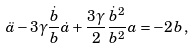<formula> <loc_0><loc_0><loc_500><loc_500>\ddot { a } - 3 \gamma \frac { \dot { b } } { b } \dot { a } + \frac { 3 \gamma } { 2 } \frac { \dot { b } ^ { 2 } } { b ^ { 2 } } a = - 2 b \, ,</formula> 